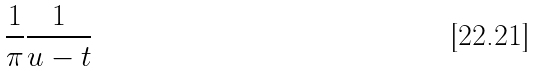<formula> <loc_0><loc_0><loc_500><loc_500>\frac { 1 } { \pi } \frac { 1 } { u - t }</formula> 